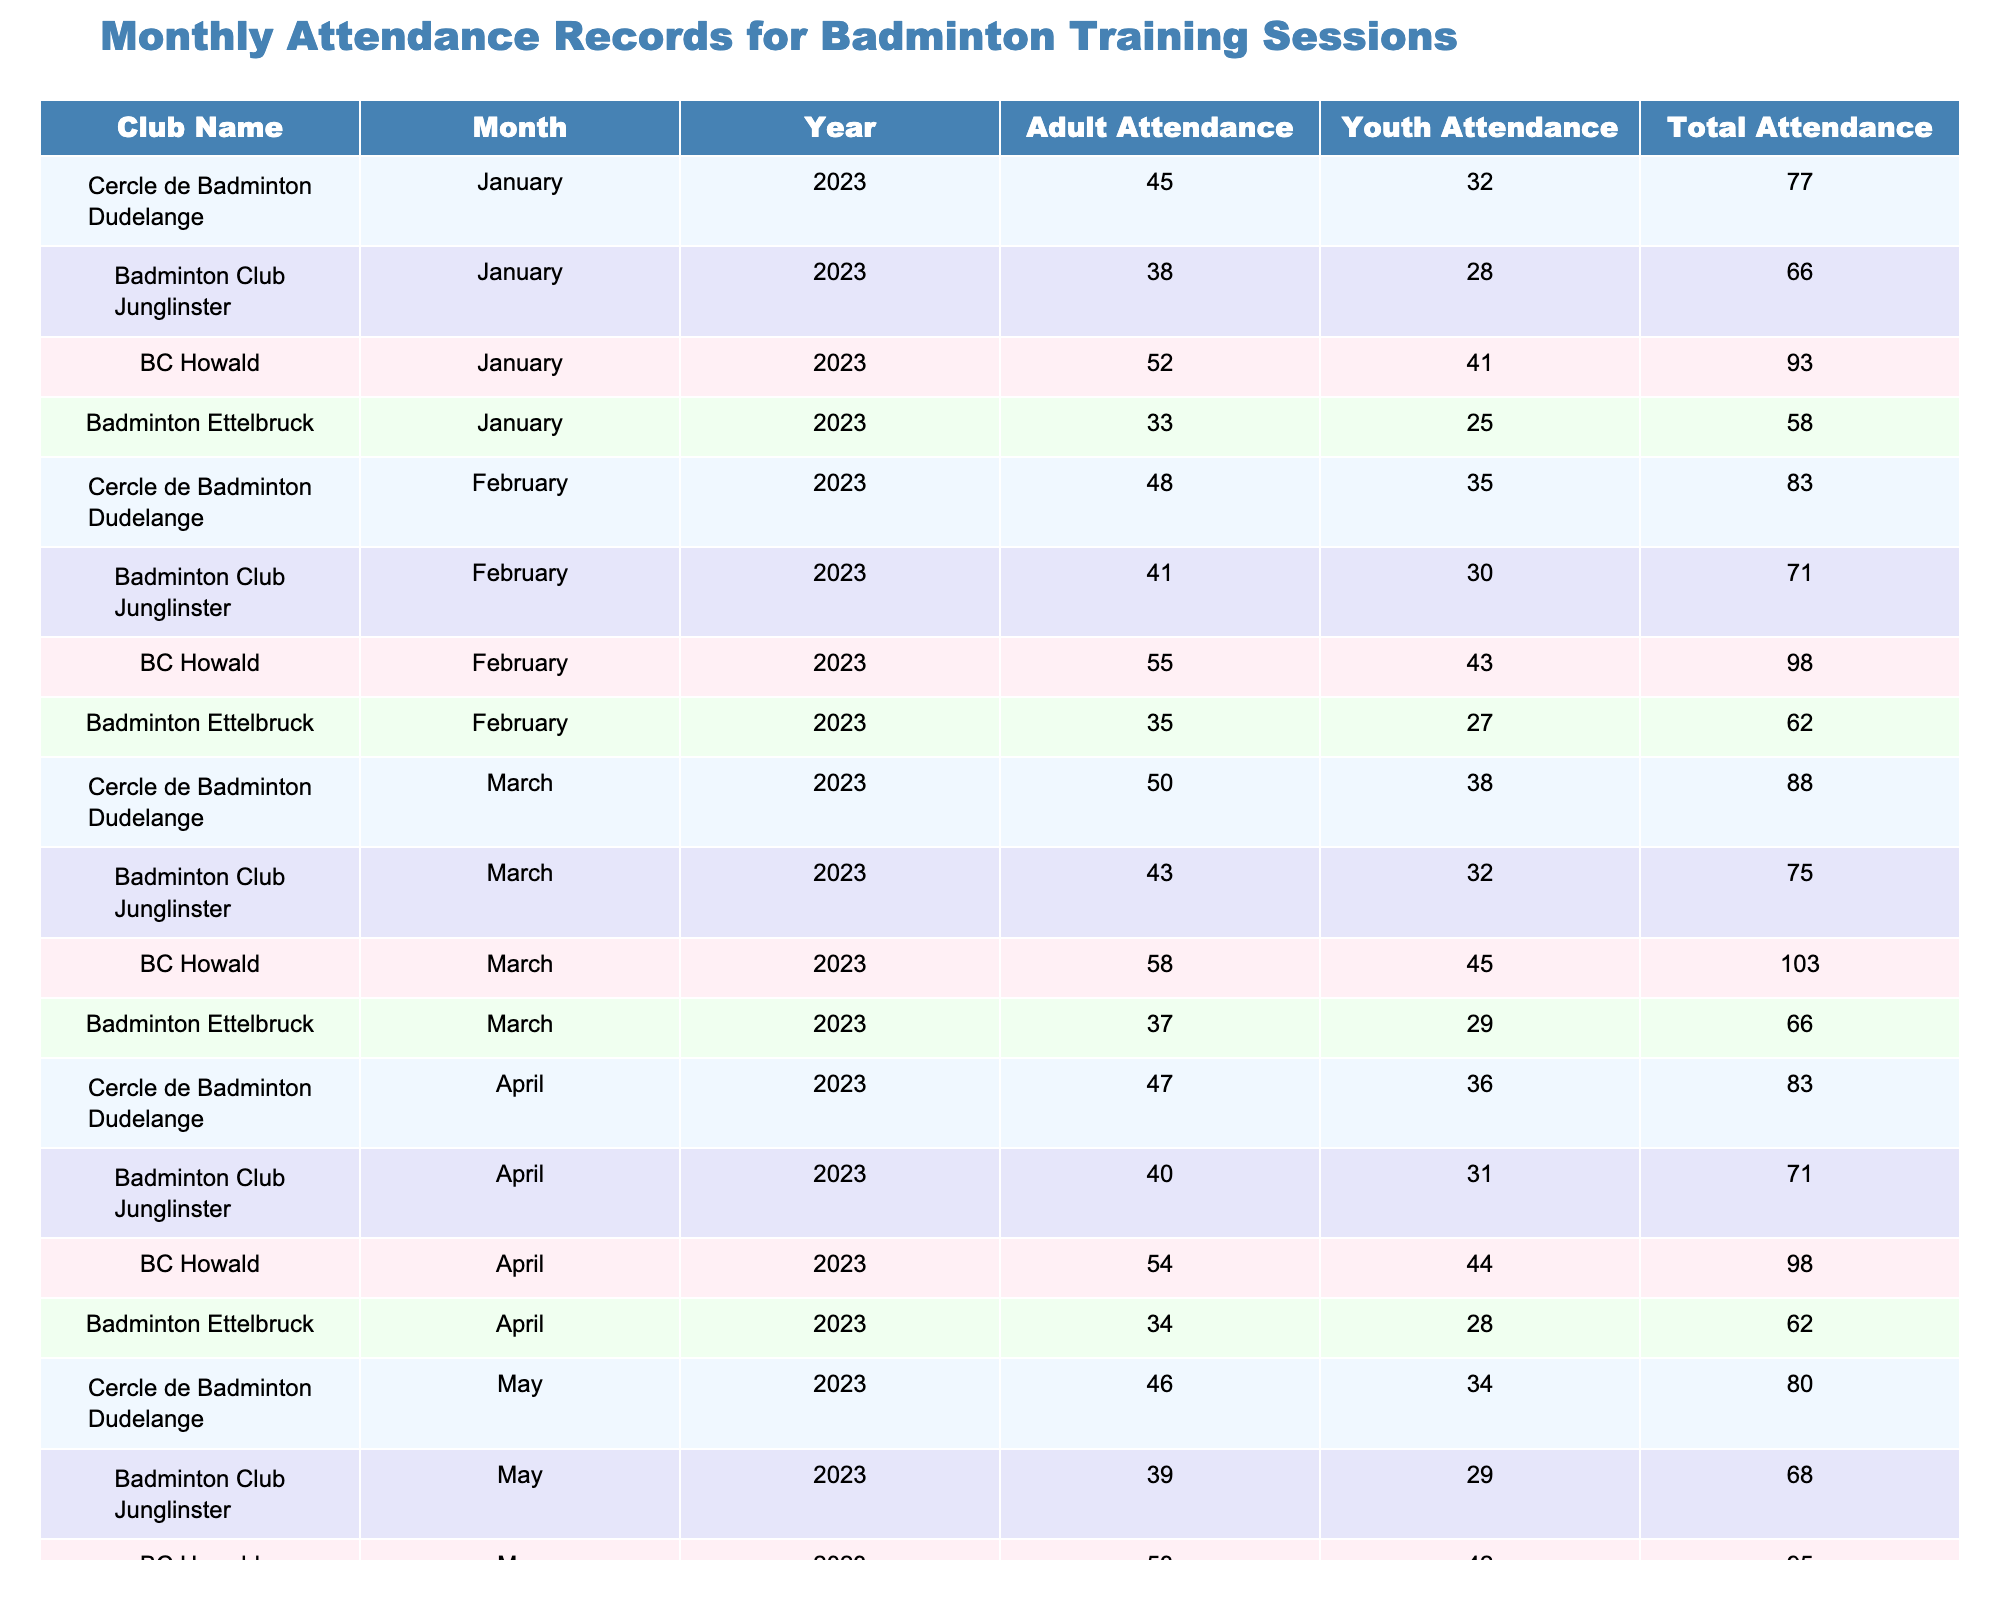What is the total attendance for Cercle de Badminton Dudelange in February 2023? The total attendance for Cercle de Badminton Dudelange in February 2023 can be found in the table under the respective month and year. It is listed as 83.
Answer: 83 Which club had the highest total attendance in March 2023? In March 2023, the total attendance for each club is listed. BC Howald had a total attendance of 103, which is higher than the other clubs in that month.
Answer: BC Howald What is the average adult attendance across all clubs for January 2023? To find the average adult attendance for January 2023, add the adult attendances of all clubs for that month: 45 + 38 + 52 + 33 = 168. There are 4 clubs, so divide 168 by 4: 168/4 = 42.
Answer: 42 Did Badminton Ettelbruck have more youth or adult attendance in April 2023? For April 2023, Badminton Ettelbruck had 28 youth attendees and 34 adult attendees. Since 34 is greater than 28, they had more adult attendance.
Answer: Adult attendance What was the change in total attendance for Badminton Club Junglinster from January to May 2023? The total attendance in January for Badminton Club Junglinster was 66, and in May it was 68. The change can be calculated as: 68 - 66 = 2.
Answer: 2 What is the total adult attendance for BC Howald for the first four months of 2023? The adult attendance figures for BC Howald from January to April are 52, 55, 58, and 54 respectively. Adding these gives: 52 + 55 + 58 + 54 = 219.
Answer: 219 Which club had the lowest youth attendance in May 2023? In May 2023, the youth attendance for each club can be checked: Cercle de Badminton Dudelange had 34, Badminton Club Junglinster had 29, BC Howald had 42, and Badminton Ettelbruck had 26. Badminton Ettelbruck had the lowest with 26.
Answer: Badminton Ettelbruck How does the total attendance for Cercle de Badminton Dudelange in March compare to their attendance in February? In February 2023, their total attendance was 83 and in March it was 88. To compare, note that 88 - 83 = 5, indicating an increase of 5 attendees in March.
Answer: Increase of 5 Was the total attendance for all clubs higher in January or February 2023? The total attendance for January 2023 is the sum of all clubs: 77 + 66 + 93 + 58 = 294. For February, it is 83 + 71 + 98 + 62 = 314. Since 314 is greater than 294, February had higher attendance.
Answer: February What is the total attendance across all clubs for May 2023? To find the total attendance for May 2023, we add the attendances: 80 + 68 + 95 + 58 = 301.
Answer: 301 Which month had the highest total attendance across all clubs? Calculate total attendance for each month: January (294), February (314), March (328), April (314), May (301). The highest total is in March with 328 attendees.
Answer: March 